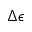Convert formula to latex. <formula><loc_0><loc_0><loc_500><loc_500>\Delta \epsilon</formula> 